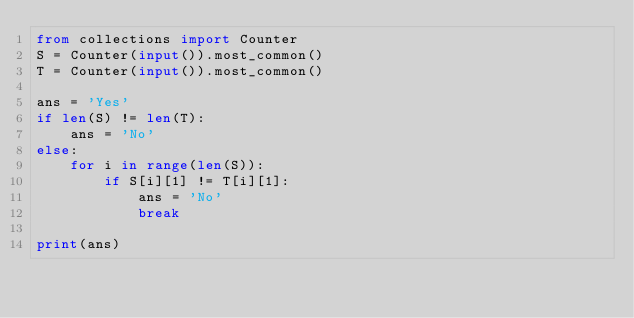Convert code to text. <code><loc_0><loc_0><loc_500><loc_500><_Python_>from collections import Counter
S = Counter(input()).most_common()
T = Counter(input()).most_common()

ans = 'Yes'
if len(S) != len(T):
    ans = 'No'
else:
    for i in range(len(S)):
        if S[i][1] != T[i][1]:
            ans = 'No'
            break
            
print(ans)</code> 